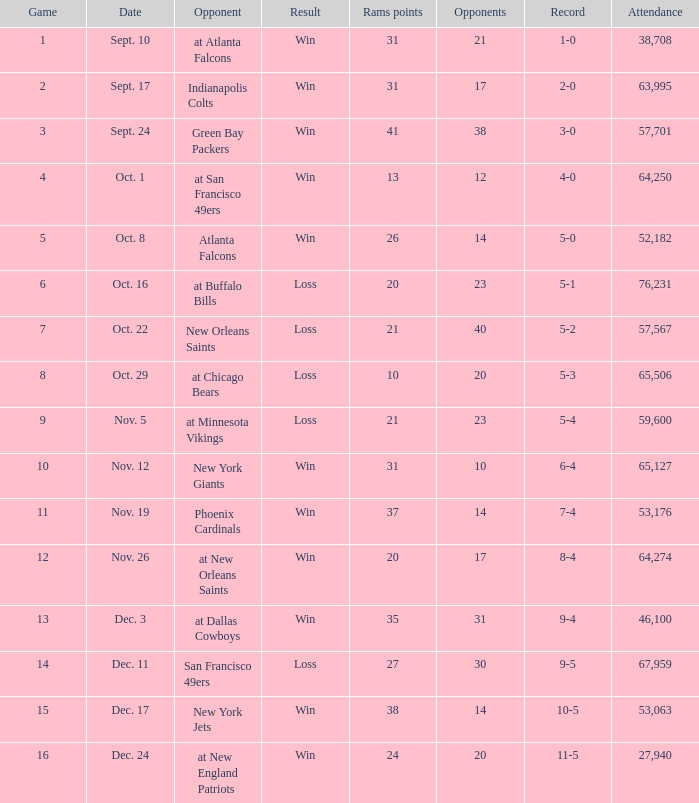What was the attendance where the record was 8-4? 64274.0. 